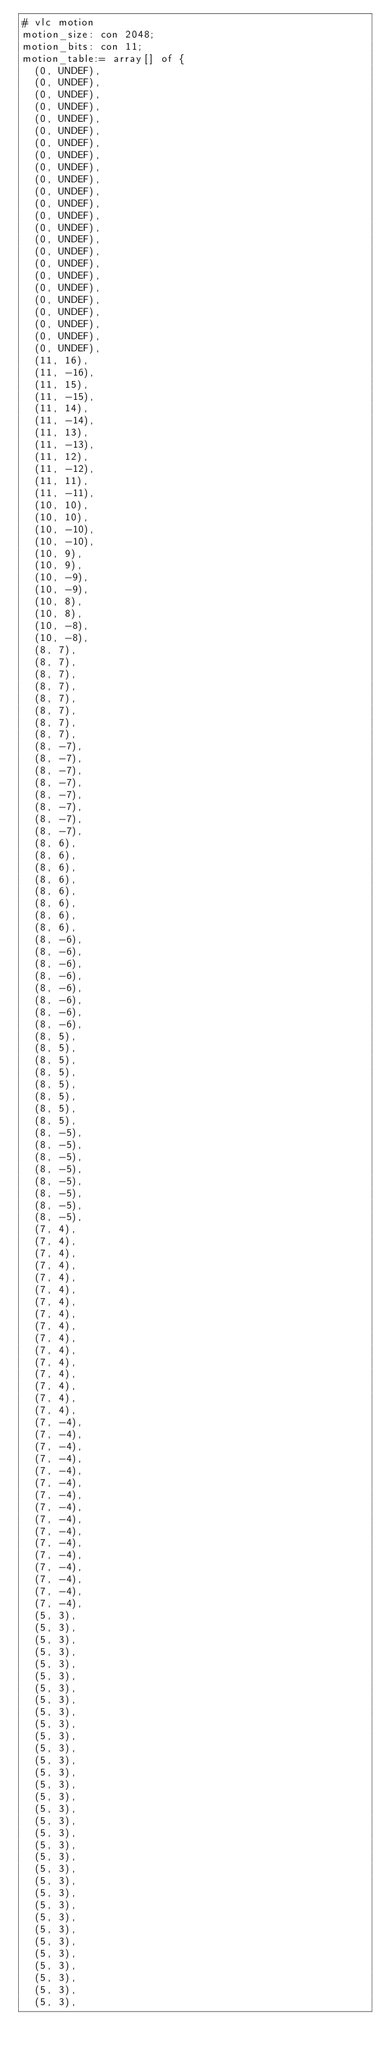Convert code to text. <code><loc_0><loc_0><loc_500><loc_500><_SQL_># vlc motion
motion_size: con 2048;
motion_bits: con 11;
motion_table:= array[] of {
	(0, UNDEF),
	(0, UNDEF),
	(0, UNDEF),
	(0, UNDEF),
	(0, UNDEF),
	(0, UNDEF),
	(0, UNDEF),
	(0, UNDEF),
	(0, UNDEF),
	(0, UNDEF),
	(0, UNDEF),
	(0, UNDEF),
	(0, UNDEF),
	(0, UNDEF),
	(0, UNDEF),
	(0, UNDEF),
	(0, UNDEF),
	(0, UNDEF),
	(0, UNDEF),
	(0, UNDEF),
	(0, UNDEF),
	(0, UNDEF),
	(0, UNDEF),
	(0, UNDEF),
	(11, 16),
	(11, -16),
	(11, 15),
	(11, -15),
	(11, 14),
	(11, -14),
	(11, 13),
	(11, -13),
	(11, 12),
	(11, -12),
	(11, 11),
	(11, -11),
	(10, 10),
	(10, 10),
	(10, -10),
	(10, -10),
	(10, 9),
	(10, 9),
	(10, -9),
	(10, -9),
	(10, 8),
	(10, 8),
	(10, -8),
	(10, -8),
	(8, 7),
	(8, 7),
	(8, 7),
	(8, 7),
	(8, 7),
	(8, 7),
	(8, 7),
	(8, 7),
	(8, -7),
	(8, -7),
	(8, -7),
	(8, -7),
	(8, -7),
	(8, -7),
	(8, -7),
	(8, -7),
	(8, 6),
	(8, 6),
	(8, 6),
	(8, 6),
	(8, 6),
	(8, 6),
	(8, 6),
	(8, 6),
	(8, -6),
	(8, -6),
	(8, -6),
	(8, -6),
	(8, -6),
	(8, -6),
	(8, -6),
	(8, -6),
	(8, 5),
	(8, 5),
	(8, 5),
	(8, 5),
	(8, 5),
	(8, 5),
	(8, 5),
	(8, 5),
	(8, -5),
	(8, -5),
	(8, -5),
	(8, -5),
	(8, -5),
	(8, -5),
	(8, -5),
	(8, -5),
	(7, 4),
	(7, 4),
	(7, 4),
	(7, 4),
	(7, 4),
	(7, 4),
	(7, 4),
	(7, 4),
	(7, 4),
	(7, 4),
	(7, 4),
	(7, 4),
	(7, 4),
	(7, 4),
	(7, 4),
	(7, 4),
	(7, -4),
	(7, -4),
	(7, -4),
	(7, -4),
	(7, -4),
	(7, -4),
	(7, -4),
	(7, -4),
	(7, -4),
	(7, -4),
	(7, -4),
	(7, -4),
	(7, -4),
	(7, -4),
	(7, -4),
	(7, -4),
	(5, 3),
	(5, 3),
	(5, 3),
	(5, 3),
	(5, 3),
	(5, 3),
	(5, 3),
	(5, 3),
	(5, 3),
	(5, 3),
	(5, 3),
	(5, 3),
	(5, 3),
	(5, 3),
	(5, 3),
	(5, 3),
	(5, 3),
	(5, 3),
	(5, 3),
	(5, 3),
	(5, 3),
	(5, 3),
	(5, 3),
	(5, 3),
	(5, 3),
	(5, 3),
	(5, 3),
	(5, 3),
	(5, 3),
	(5, 3),
	(5, 3),
	(5, 3),
	(5, 3),</code> 